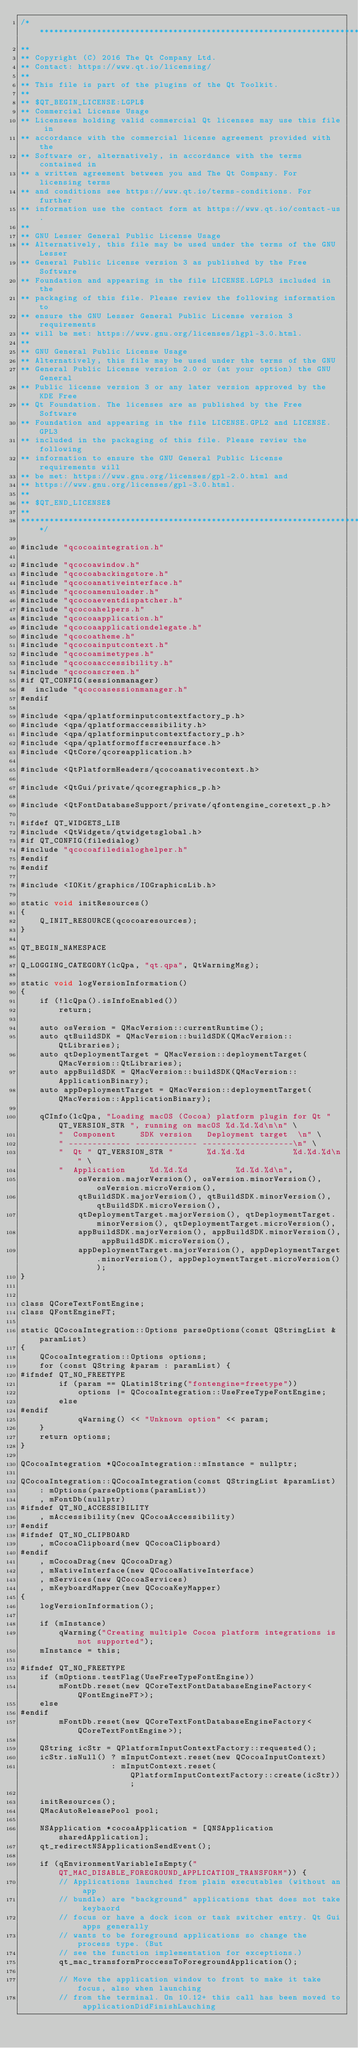<code> <loc_0><loc_0><loc_500><loc_500><_ObjectiveC_>/****************************************************************************
**
** Copyright (C) 2016 The Qt Company Ltd.
** Contact: https://www.qt.io/licensing/
**
** This file is part of the plugins of the Qt Toolkit.
**
** $QT_BEGIN_LICENSE:LGPL$
** Commercial License Usage
** Licensees holding valid commercial Qt licenses may use this file in
** accordance with the commercial license agreement provided with the
** Software or, alternatively, in accordance with the terms contained in
** a written agreement between you and The Qt Company. For licensing terms
** and conditions see https://www.qt.io/terms-conditions. For further
** information use the contact form at https://www.qt.io/contact-us.
**
** GNU Lesser General Public License Usage
** Alternatively, this file may be used under the terms of the GNU Lesser
** General Public License version 3 as published by the Free Software
** Foundation and appearing in the file LICENSE.LGPL3 included in the
** packaging of this file. Please review the following information to
** ensure the GNU Lesser General Public License version 3 requirements
** will be met: https://www.gnu.org/licenses/lgpl-3.0.html.
**
** GNU General Public License Usage
** Alternatively, this file may be used under the terms of the GNU
** General Public License version 2.0 or (at your option) the GNU General
** Public license version 3 or any later version approved by the KDE Free
** Qt Foundation. The licenses are as published by the Free Software
** Foundation and appearing in the file LICENSE.GPL2 and LICENSE.GPL3
** included in the packaging of this file. Please review the following
** information to ensure the GNU General Public License requirements will
** be met: https://www.gnu.org/licenses/gpl-2.0.html and
** https://www.gnu.org/licenses/gpl-3.0.html.
**
** $QT_END_LICENSE$
**
****************************************************************************/

#include "qcocoaintegration.h"

#include "qcocoawindow.h"
#include "qcocoabackingstore.h"
#include "qcocoanativeinterface.h"
#include "qcocoamenuloader.h"
#include "qcocoaeventdispatcher.h"
#include "qcocoahelpers.h"
#include "qcocoaapplication.h"
#include "qcocoaapplicationdelegate.h"
#include "qcocoatheme.h"
#include "qcocoainputcontext.h"
#include "qcocoamimetypes.h"
#include "qcocoaaccessibility.h"
#include "qcocoascreen.h"
#if QT_CONFIG(sessionmanager)
#  include "qcocoasessionmanager.h"
#endif

#include <qpa/qplatforminputcontextfactory_p.h>
#include <qpa/qplatformaccessibility.h>
#include <qpa/qplatforminputcontextfactory_p.h>
#include <qpa/qplatformoffscreensurface.h>
#include <QtCore/qcoreapplication.h>

#include <QtPlatformHeaders/qcocoanativecontext.h>

#include <QtGui/private/qcoregraphics_p.h>

#include <QtFontDatabaseSupport/private/qfontengine_coretext_p.h>

#ifdef QT_WIDGETS_LIB
#include <QtWidgets/qtwidgetsglobal.h>
#if QT_CONFIG(filedialog)
#include "qcocoafiledialoghelper.h"
#endif
#endif

#include <IOKit/graphics/IOGraphicsLib.h>

static void initResources()
{
    Q_INIT_RESOURCE(qcocoaresources);
}

QT_BEGIN_NAMESPACE

Q_LOGGING_CATEGORY(lcQpa, "qt.qpa", QtWarningMsg);

static void logVersionInformation()
{
    if (!lcQpa().isInfoEnabled())
        return;

    auto osVersion = QMacVersion::currentRuntime();
    auto qtBuildSDK = QMacVersion::buildSDK(QMacVersion::QtLibraries);
    auto qtDeploymentTarget = QMacVersion::deploymentTarget(QMacVersion::QtLibraries);
    auto appBuildSDK = QMacVersion::buildSDK(QMacVersion::ApplicationBinary);
    auto appDeploymentTarget = QMacVersion::deploymentTarget(QMacVersion::ApplicationBinary);

    qCInfo(lcQpa, "Loading macOS (Cocoa) platform plugin for Qt " QT_VERSION_STR ", running on macOS %d.%d.%d\n\n" \
        "  Component     SDK version   Deployment target  \n" \
        " ------------- ------------- -------------------\n" \
        "  Qt " QT_VERSION_STR "       %d.%d.%d          %d.%d.%d\n" \
        "  Application     %d.%d.%d          %d.%d.%d\n",
            osVersion.majorVersion(), osVersion.minorVersion(), osVersion.microVersion(),
            qtBuildSDK.majorVersion(), qtBuildSDK.minorVersion(), qtBuildSDK.microVersion(),
            qtDeploymentTarget.majorVersion(), qtDeploymentTarget.minorVersion(), qtDeploymentTarget.microVersion(),
            appBuildSDK.majorVersion(), appBuildSDK.minorVersion(), appBuildSDK.microVersion(),
            appDeploymentTarget.majorVersion(), appDeploymentTarget.minorVersion(), appDeploymentTarget.microVersion());
}


class QCoreTextFontEngine;
class QFontEngineFT;

static QCocoaIntegration::Options parseOptions(const QStringList &paramList)
{
    QCocoaIntegration::Options options;
    for (const QString &param : paramList) {
#ifndef QT_NO_FREETYPE
        if (param == QLatin1String("fontengine=freetype"))
            options |= QCocoaIntegration::UseFreeTypeFontEngine;
        else
#endif
            qWarning() << "Unknown option" << param;
    }
    return options;
}

QCocoaIntegration *QCocoaIntegration::mInstance = nullptr;

QCocoaIntegration::QCocoaIntegration(const QStringList &paramList)
    : mOptions(parseOptions(paramList))
    , mFontDb(nullptr)
#ifndef QT_NO_ACCESSIBILITY
    , mAccessibility(new QCocoaAccessibility)
#endif
#ifndef QT_NO_CLIPBOARD
    , mCocoaClipboard(new QCocoaClipboard)
#endif
    , mCocoaDrag(new QCocoaDrag)
    , mNativeInterface(new QCocoaNativeInterface)
    , mServices(new QCocoaServices)
    , mKeyboardMapper(new QCocoaKeyMapper)
{
    logVersionInformation();

    if (mInstance)
        qWarning("Creating multiple Cocoa platform integrations is not supported");
    mInstance = this;

#ifndef QT_NO_FREETYPE
    if (mOptions.testFlag(UseFreeTypeFontEngine))
        mFontDb.reset(new QCoreTextFontDatabaseEngineFactory<QFontEngineFT>);
    else
#endif
        mFontDb.reset(new QCoreTextFontDatabaseEngineFactory<QCoreTextFontEngine>);

    QString icStr = QPlatformInputContextFactory::requested();
    icStr.isNull() ? mInputContext.reset(new QCocoaInputContext)
                   : mInputContext.reset(QPlatformInputContextFactory::create(icStr));

    initResources();
    QMacAutoReleasePool pool;

    NSApplication *cocoaApplication = [QNSApplication sharedApplication];
    qt_redirectNSApplicationSendEvent();

    if (qEnvironmentVariableIsEmpty("QT_MAC_DISABLE_FOREGROUND_APPLICATION_TRANSFORM")) {
        // Applications launched from plain executables (without an app
        // bundle) are "background" applications that does not take keybaord
        // focus or have a dock icon or task switcher entry. Qt Gui apps generally
        // wants to be foreground applications so change the process type. (But
        // see the function implementation for exceptions.)
        qt_mac_transformProccessToForegroundApplication();

        // Move the application window to front to make it take focus, also when launching
        // from the terminal. On 10.12+ this call has been moved to applicationDidFinishLauching</code> 